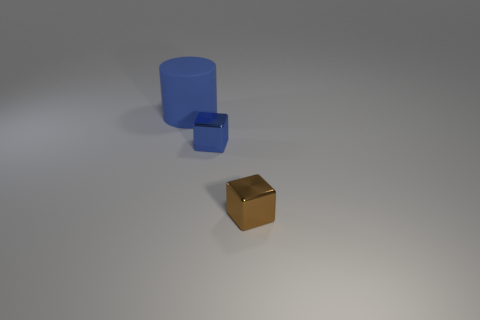Add 1 brown cubes. How many objects exist? 4 Subtract all cylinders. How many objects are left? 2 Add 1 shiny spheres. How many shiny spheres exist? 1 Subtract 0 green cylinders. How many objects are left? 3 Subtract all rubber cylinders. Subtract all brown matte cubes. How many objects are left? 2 Add 2 big matte cylinders. How many big matte cylinders are left? 3 